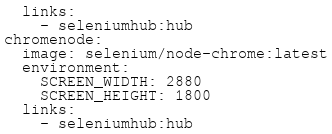Convert code to text. <code><loc_0><loc_0><loc_500><loc_500><_YAML_>  links:
    - seleniumhub:hub
chromenode:
  image: selenium/node-chrome:latest
  environment:
    SCREEN_WIDTH: 2880
    SCREEN_HEIGHT: 1800
  links:
    - seleniumhub:hub</code> 